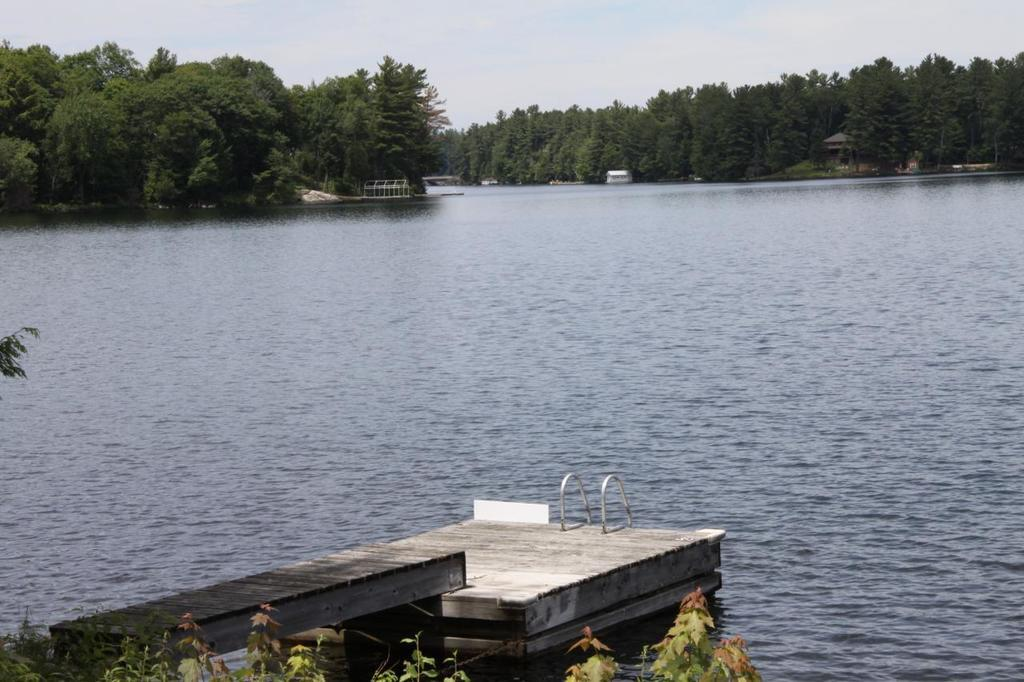What is the main subject in the foreground of the image? There is a dog in the foreground of the image. What can be seen in the image besides the dog? There is a water surface visible in the image. What type of natural environment is depicted in the background of the image? There are trees in the background of the image. How many wheels can be seen on the dog in the image? Dogs do not have wheels, so none can be seen on the dog in the image. 